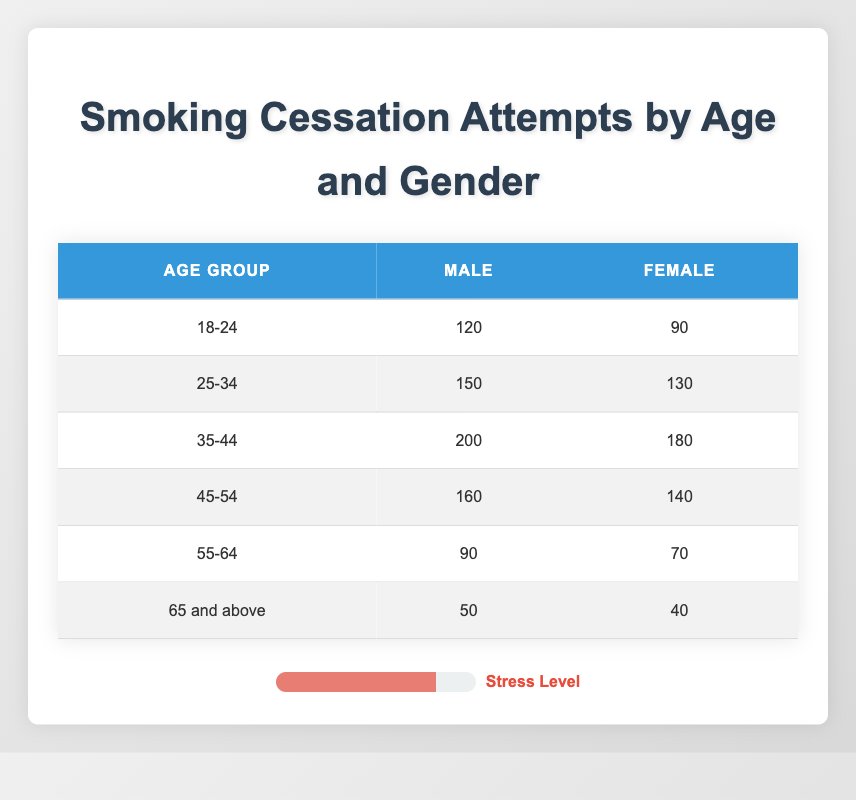What is the total number of smoking cessation attempts for males aged 18-24? According to the table, the number of smoking cessation attempts for males aged 18-24 is 120. Thus, the total is simply 120.
Answer: 120 What is the total number of smoking cessation attempts for females in the age group 45-54? The table indicates that the number of attempts for females in the 45-54 age group is 140. Therefore, the total is 140.
Answer: 140 Who had more smoking cessation attempts, males or females, in the age group 35-44? The table shows that males had 200 attempts and females had 180 attempts in the age group 35-44. Since 200 > 180, males had more attempts.
Answer: Males What is the difference in smoking cessation attempts between males and females in the age group 25-34? For the age group 25-34, males had 150 attempts and females had 130 attempts. The difference is 150 - 130, which equals 20.
Answer: 20 What is the average number of smoking cessation attempts for all age groups combined for males? To calculate the average for males, we first sum the attempts: 120 + 150 + 200 + 160 + 90 + 50 = 770. There are 6 age groups. Thus, the average is 770 / 6, which equals approximately 128.33.
Answer: 128.33 Is it true that females aged 65 and above had more cessation attempts than males in the same age group? The table states that females aged 65 and above had 40 attempts while males had 50 attempts. Since 40 is less than 50, this statement is false.
Answer: False Which age group had the highest total smoking cessation attempts overall? To determine this, we sum the attempts for each age group: 18-24 (210), 25-34 (280), 35-44 (380), 45-54 (300), 55-64 (160), and 65 and above (90). The highest sum is 380 for the age group 35-44.
Answer: 35-44 What proportion of total smoking cessation attempts do males represent in the 55-64 age group? For the 55-64 age group, males had 90 attempts and females had 70 attempts. The total for this age group is 90 + 70 = 160. The proportion for males is 90 / 160, which simplifies to 0.5625 or 56.25%.
Answer: 56.25% How many more attempts did males have than females in the entire dataset? To find this, we first calculate the total attempts for males: 120 + 150 + 200 + 160 + 90 + 50 = 770, and for females: 90 + 130 + 180 + 140 + 70 + 40 = 650. The difference is 770 - 650 = 120.
Answer: 120 